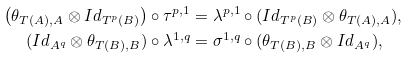<formula> <loc_0><loc_0><loc_500><loc_500>\left ( \theta _ { T ( A ) , A } \otimes I d _ { T ^ { p } ( B ) } \right ) \circ \tau ^ { p , 1 } & = \lambda ^ { p , 1 } \circ ( I d _ { T ^ { p } ( B ) } \otimes \theta _ { T ( A ) , A } ) , \\ ( I d _ { A ^ { q } } \otimes \theta _ { T ( B ) , B } ) \circ \lambda ^ { 1 , q } & = \sigma ^ { 1 , q } \circ ( \theta _ { T ( B ) , B } \otimes I d _ { A ^ { q } } ) ,</formula> 